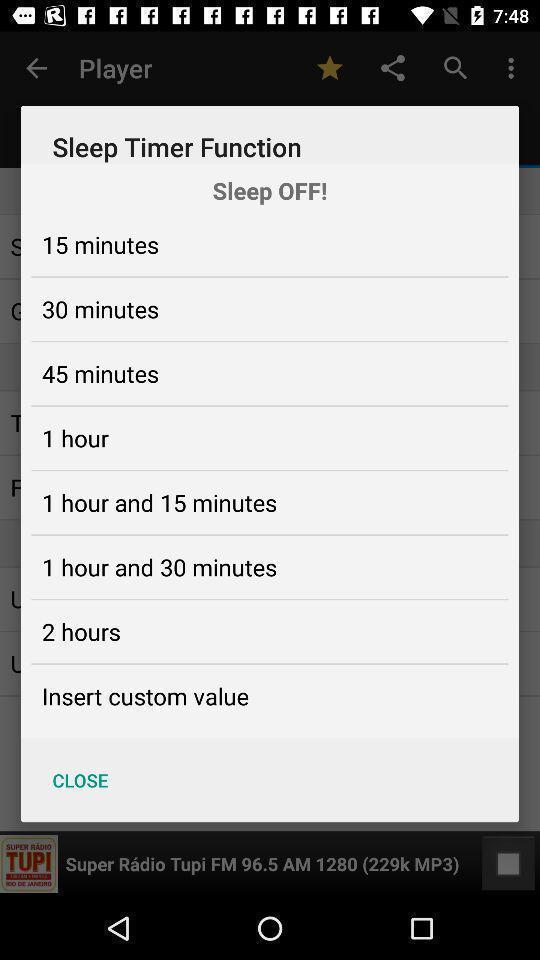Explain what's happening in this screen capture. Pop-up for various sleep timer function timings setup. 